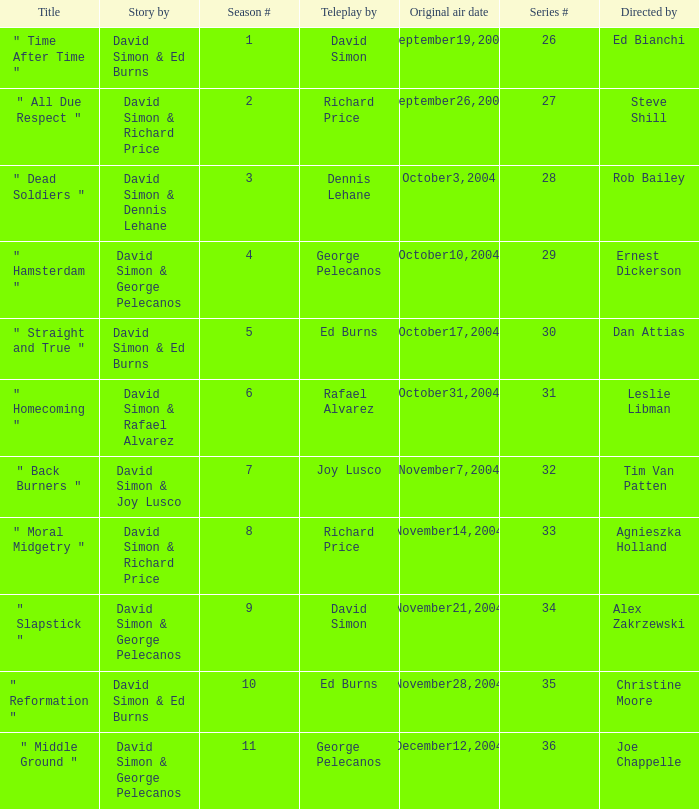What is the season # for a teleplay by Richard Price and the director is Steve Shill? 2.0. 